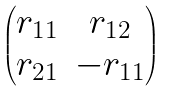Convert formula to latex. <formula><loc_0><loc_0><loc_500><loc_500>\begin{pmatrix} r _ { 1 1 } & r _ { 1 2 } \\ r _ { 2 1 } & - r _ { 1 1 } \end{pmatrix}</formula> 